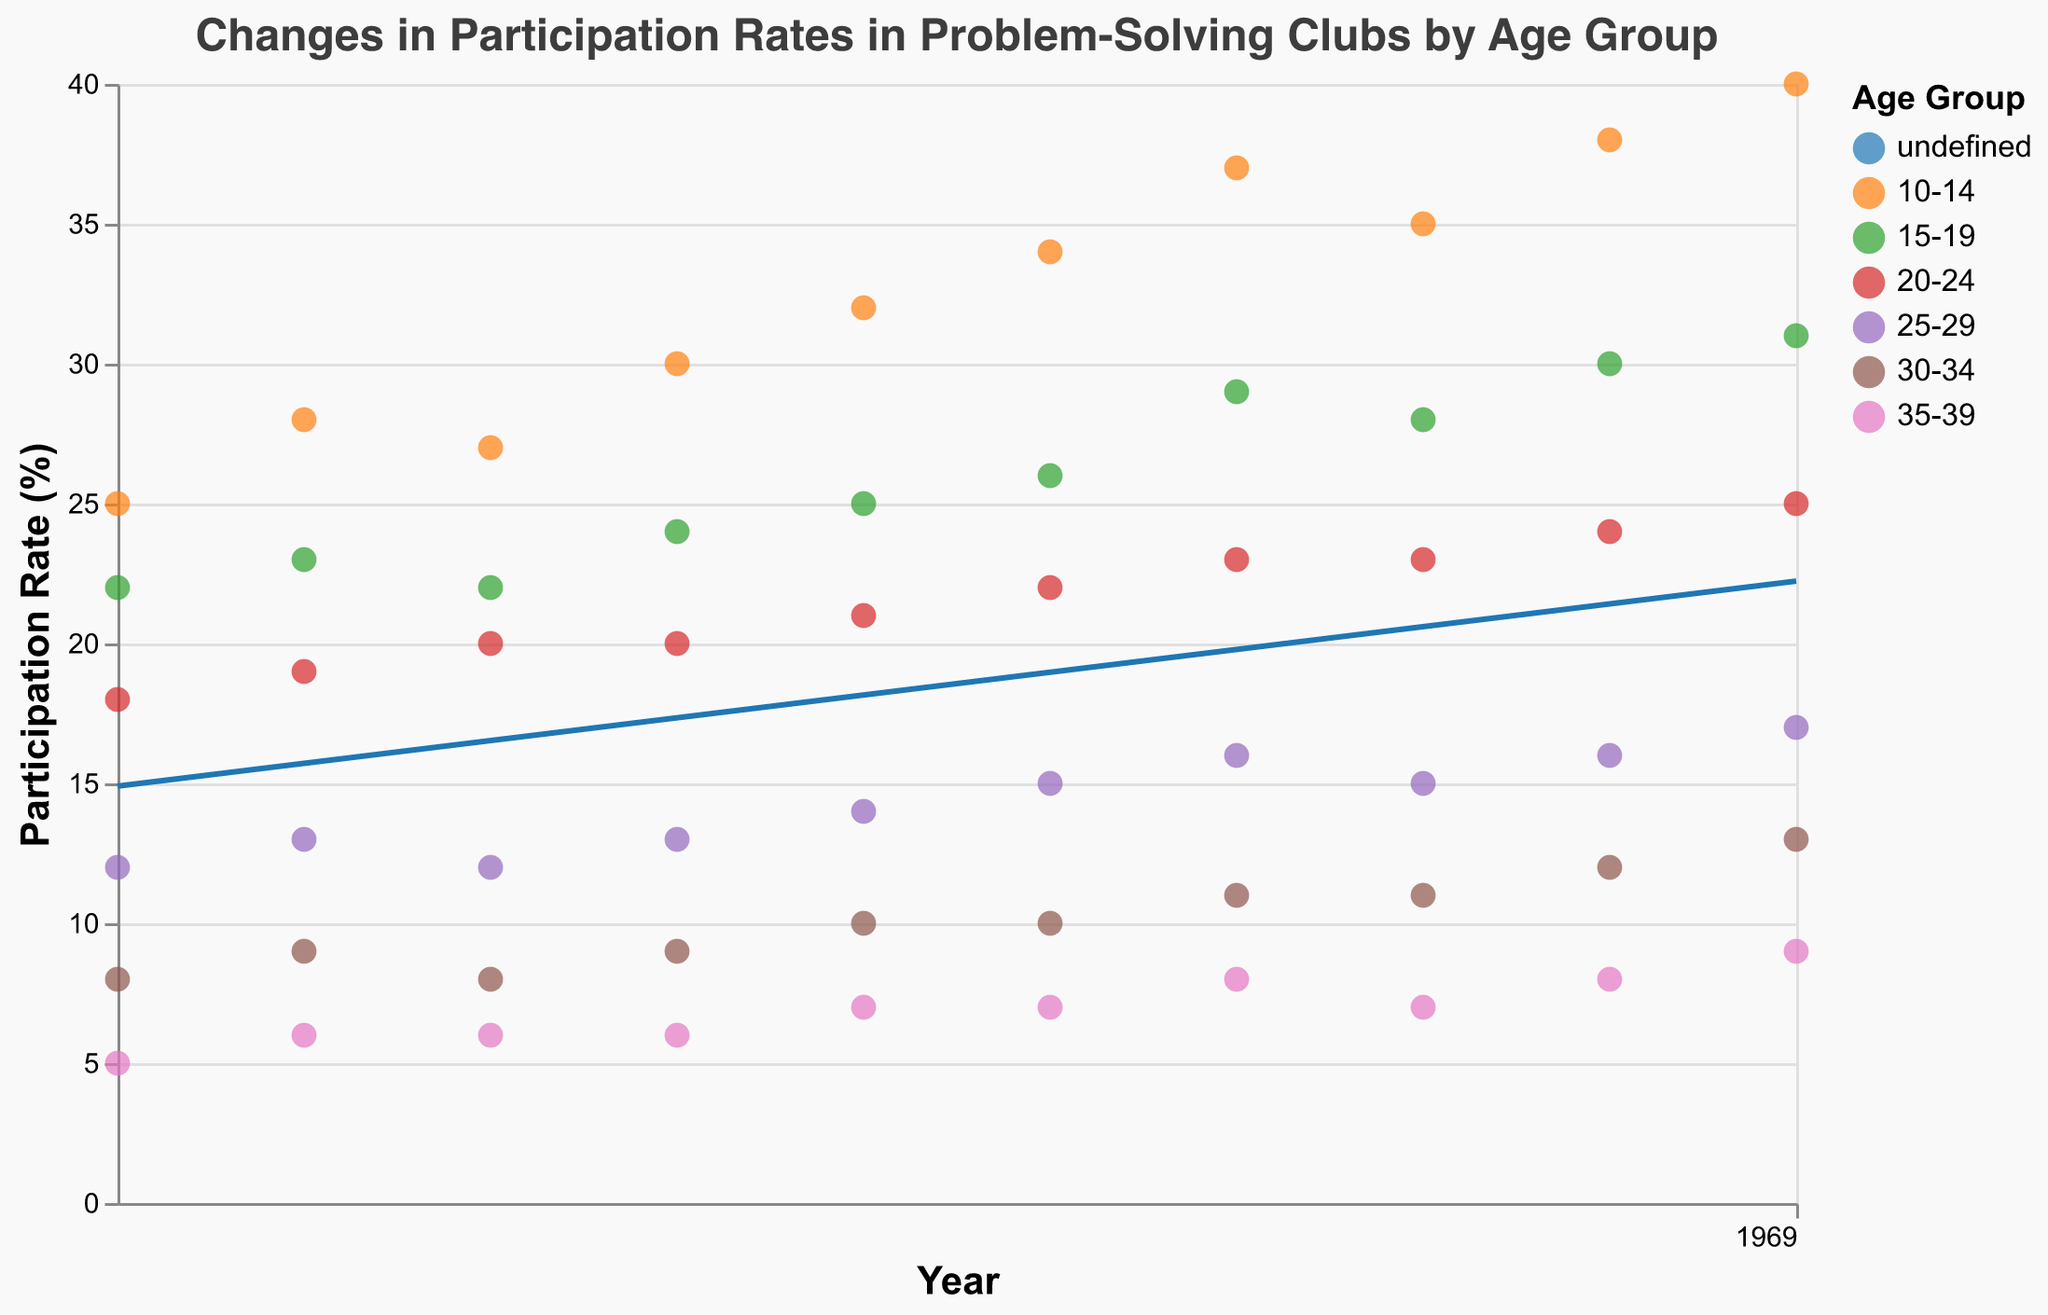What's the highest participation rate recorded for the 10-14 age group? To find the highest participation rate for the 10-14 age group, look for the peak point in the scatter plot trend line of this group. According to the figure, the highest point is at 40% in 2022.
Answer: 40% Which age groups have shown an upward trend in participation rates over the past decade? To determine the age groups with upward trends, analyze the slope of the trend lines for each group. The 10-14, 15-19, 20-24, 25-29, 30-34, and 35-39 age groups all show an increasing trend in participation rates over the years.
Answer: All age groups What's the trend line color for the 20-24 age group? Identify the color assigned to the 20-24 age group in the legend and match it to the corresponding trend line in the scatter plot.
Answer: (identify the color) How much did the participation rate for the 15-19 age group increase from 2013 to 2022? To find the increase, subtract the participation rate in 2013 from the rate in 2022 for the 15-19 age group: 31% (2022) - 22% (2013).
Answer: 9% For which year did the 10-14 age group see the largest jump in participation rate compared to the previous year? Compare the year-over-year differences in the participation rate for the 10-14 age group. The largest jump is from 34% in 2018 to 37% in 2019, a 3% increase.
Answer: 2019 What is the overall trend for participation rates in the 35-39 age group? Check the trend line and the increasing or decreasing nature of the participation rates over the time span. The participation rate for the 35-39 age group has shown a steady increase from 5% in 2013 to 9% in 2022.
Answer: Upward Which age group showed the least participation rate in 2022? Compare the end points of each trend line in 2022 and find the group with the lowest value. The 35-39 age group had the least participation rate at 9% in 2022.
Answer: 35-39 